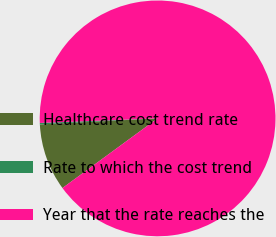<chart> <loc_0><loc_0><loc_500><loc_500><pie_chart><fcel>Healthcare cost trend rate<fcel>Rate to which the cost trend<fcel>Year that the rate reaches the<nl><fcel>9.24%<fcel>0.2%<fcel>90.56%<nl></chart> 